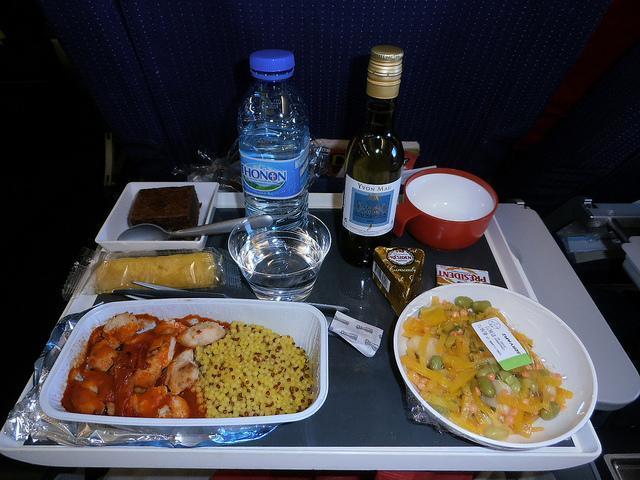How many bowls are there?
Give a very brief answer. 3. How many bottles are there?
Give a very brief answer. 2. How many cups are in the picture?
Give a very brief answer. 2. 